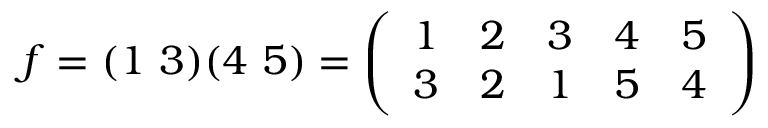Convert formula to latex. <formula><loc_0><loc_0><loc_500><loc_500>f = ( 1 \ 3 ) ( 4 \ 5 ) = { \left ( \begin{array} { l l l l l } { 1 } & { 2 } & { 3 } & { 4 } & { 5 } \\ { 3 } & { 2 } & { 1 } & { 5 } & { 4 } \end{array} \right ) }</formula> 